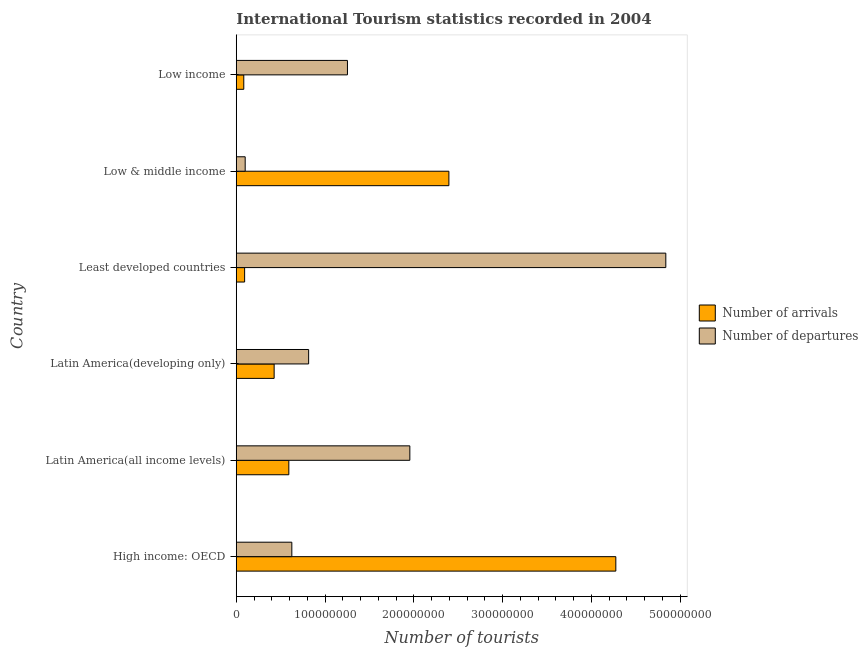How many different coloured bars are there?
Provide a short and direct response. 2. How many groups of bars are there?
Your answer should be compact. 6. Are the number of bars per tick equal to the number of legend labels?
Make the answer very short. Yes. How many bars are there on the 1st tick from the bottom?
Your answer should be compact. 2. What is the label of the 4th group of bars from the top?
Offer a very short reply. Latin America(developing only). What is the number of tourist departures in Low income?
Give a very brief answer. 1.25e+08. Across all countries, what is the maximum number of tourist departures?
Make the answer very short. 4.84e+08. Across all countries, what is the minimum number of tourist departures?
Offer a very short reply. 1.01e+07. In which country was the number of tourist arrivals maximum?
Provide a short and direct response. High income: OECD. What is the total number of tourist arrivals in the graph?
Your answer should be very brief. 7.87e+08. What is the difference between the number of tourist arrivals in High income: OECD and that in Low income?
Offer a terse response. 4.19e+08. What is the difference between the number of tourist arrivals in Least developed countries and the number of tourist departures in Latin America(all income levels)?
Provide a succinct answer. -1.86e+08. What is the average number of tourist departures per country?
Your answer should be very brief. 1.60e+08. What is the difference between the number of tourist departures and number of tourist arrivals in Low income?
Provide a succinct answer. 1.17e+08. What is the ratio of the number of tourist departures in High income: OECD to that in Least developed countries?
Your answer should be compact. 0.13. Is the number of tourist arrivals in High income: OECD less than that in Low income?
Your answer should be compact. No. What is the difference between the highest and the second highest number of tourist arrivals?
Provide a succinct answer. 1.88e+08. What is the difference between the highest and the lowest number of tourist arrivals?
Keep it short and to the point. 4.19e+08. What does the 1st bar from the top in Low & middle income represents?
Your answer should be very brief. Number of departures. What does the 1st bar from the bottom in Low income represents?
Ensure brevity in your answer.  Number of arrivals. Are all the bars in the graph horizontal?
Offer a terse response. Yes. How many countries are there in the graph?
Keep it short and to the point. 6. What is the difference between two consecutive major ticks on the X-axis?
Offer a terse response. 1.00e+08. Does the graph contain any zero values?
Ensure brevity in your answer.  No. Does the graph contain grids?
Keep it short and to the point. No. Where does the legend appear in the graph?
Give a very brief answer. Center right. What is the title of the graph?
Offer a very short reply. International Tourism statistics recorded in 2004. Does "Female entrants" appear as one of the legend labels in the graph?
Your answer should be very brief. No. What is the label or title of the X-axis?
Give a very brief answer. Number of tourists. What is the label or title of the Y-axis?
Your answer should be very brief. Country. What is the Number of tourists in Number of arrivals in High income: OECD?
Offer a very short reply. 4.28e+08. What is the Number of tourists of Number of departures in High income: OECD?
Provide a succinct answer. 6.26e+07. What is the Number of tourists of Number of arrivals in Latin America(all income levels)?
Provide a succinct answer. 5.92e+07. What is the Number of tourists of Number of departures in Latin America(all income levels)?
Provide a short and direct response. 1.96e+08. What is the Number of tourists in Number of arrivals in Latin America(developing only)?
Your response must be concise. 4.27e+07. What is the Number of tourists of Number of departures in Latin America(developing only)?
Offer a terse response. 8.16e+07. What is the Number of tourists of Number of arrivals in Least developed countries?
Make the answer very short. 9.43e+06. What is the Number of tourists of Number of departures in Least developed countries?
Your response must be concise. 4.84e+08. What is the Number of tourists of Number of arrivals in Low & middle income?
Offer a very short reply. 2.40e+08. What is the Number of tourists in Number of departures in Low & middle income?
Keep it short and to the point. 1.01e+07. What is the Number of tourists in Number of arrivals in Low income?
Provide a short and direct response. 8.48e+06. What is the Number of tourists in Number of departures in Low income?
Provide a succinct answer. 1.25e+08. Across all countries, what is the maximum Number of tourists of Number of arrivals?
Provide a succinct answer. 4.28e+08. Across all countries, what is the maximum Number of tourists in Number of departures?
Offer a terse response. 4.84e+08. Across all countries, what is the minimum Number of tourists in Number of arrivals?
Give a very brief answer. 8.48e+06. Across all countries, what is the minimum Number of tourists of Number of departures?
Offer a very short reply. 1.01e+07. What is the total Number of tourists in Number of arrivals in the graph?
Your answer should be compact. 7.87e+08. What is the total Number of tourists in Number of departures in the graph?
Give a very brief answer. 9.59e+08. What is the difference between the Number of tourists of Number of arrivals in High income: OECD and that in Latin America(all income levels)?
Ensure brevity in your answer.  3.68e+08. What is the difference between the Number of tourists in Number of departures in High income: OECD and that in Latin America(all income levels)?
Offer a very short reply. -1.33e+08. What is the difference between the Number of tourists in Number of arrivals in High income: OECD and that in Latin America(developing only)?
Offer a very short reply. 3.85e+08. What is the difference between the Number of tourists in Number of departures in High income: OECD and that in Latin America(developing only)?
Offer a terse response. -1.90e+07. What is the difference between the Number of tourists of Number of arrivals in High income: OECD and that in Least developed countries?
Give a very brief answer. 4.18e+08. What is the difference between the Number of tourists of Number of departures in High income: OECD and that in Least developed countries?
Make the answer very short. -4.21e+08. What is the difference between the Number of tourists of Number of arrivals in High income: OECD and that in Low & middle income?
Keep it short and to the point. 1.88e+08. What is the difference between the Number of tourists of Number of departures in High income: OECD and that in Low & middle income?
Your response must be concise. 5.25e+07. What is the difference between the Number of tourists of Number of arrivals in High income: OECD and that in Low income?
Your response must be concise. 4.19e+08. What is the difference between the Number of tourists in Number of departures in High income: OECD and that in Low income?
Your answer should be compact. -6.27e+07. What is the difference between the Number of tourists in Number of arrivals in Latin America(all income levels) and that in Latin America(developing only)?
Offer a terse response. 1.66e+07. What is the difference between the Number of tourists in Number of departures in Latin America(all income levels) and that in Latin America(developing only)?
Make the answer very short. 1.14e+08. What is the difference between the Number of tourists of Number of arrivals in Latin America(all income levels) and that in Least developed countries?
Provide a succinct answer. 4.98e+07. What is the difference between the Number of tourists in Number of departures in Latin America(all income levels) and that in Least developed countries?
Keep it short and to the point. -2.88e+08. What is the difference between the Number of tourists of Number of arrivals in Latin America(all income levels) and that in Low & middle income?
Keep it short and to the point. -1.80e+08. What is the difference between the Number of tourists of Number of departures in Latin America(all income levels) and that in Low & middle income?
Offer a terse response. 1.86e+08. What is the difference between the Number of tourists in Number of arrivals in Latin America(all income levels) and that in Low income?
Offer a terse response. 5.08e+07. What is the difference between the Number of tourists in Number of departures in Latin America(all income levels) and that in Low income?
Provide a succinct answer. 7.03e+07. What is the difference between the Number of tourists in Number of arrivals in Latin America(developing only) and that in Least developed countries?
Make the answer very short. 3.33e+07. What is the difference between the Number of tourists of Number of departures in Latin America(developing only) and that in Least developed countries?
Ensure brevity in your answer.  -4.02e+08. What is the difference between the Number of tourists in Number of arrivals in Latin America(developing only) and that in Low & middle income?
Provide a short and direct response. -1.97e+08. What is the difference between the Number of tourists of Number of departures in Latin America(developing only) and that in Low & middle income?
Your response must be concise. 7.15e+07. What is the difference between the Number of tourists of Number of arrivals in Latin America(developing only) and that in Low income?
Provide a succinct answer. 3.42e+07. What is the difference between the Number of tourists of Number of departures in Latin America(developing only) and that in Low income?
Give a very brief answer. -4.37e+07. What is the difference between the Number of tourists in Number of arrivals in Least developed countries and that in Low & middle income?
Offer a very short reply. -2.30e+08. What is the difference between the Number of tourists of Number of departures in Least developed countries and that in Low & middle income?
Your response must be concise. 4.74e+08. What is the difference between the Number of tourists in Number of arrivals in Least developed countries and that in Low income?
Offer a terse response. 9.46e+05. What is the difference between the Number of tourists of Number of departures in Least developed countries and that in Low income?
Your answer should be compact. 3.59e+08. What is the difference between the Number of tourists in Number of arrivals in Low & middle income and that in Low income?
Give a very brief answer. 2.31e+08. What is the difference between the Number of tourists of Number of departures in Low & middle income and that in Low income?
Give a very brief answer. -1.15e+08. What is the difference between the Number of tourists in Number of arrivals in High income: OECD and the Number of tourists in Number of departures in Latin America(all income levels)?
Your response must be concise. 2.32e+08. What is the difference between the Number of tourists in Number of arrivals in High income: OECD and the Number of tourists in Number of departures in Latin America(developing only)?
Your response must be concise. 3.46e+08. What is the difference between the Number of tourists in Number of arrivals in High income: OECD and the Number of tourists in Number of departures in Least developed countries?
Ensure brevity in your answer.  -5.63e+07. What is the difference between the Number of tourists in Number of arrivals in High income: OECD and the Number of tourists in Number of departures in Low & middle income?
Offer a terse response. 4.18e+08. What is the difference between the Number of tourists in Number of arrivals in High income: OECD and the Number of tourists in Number of departures in Low income?
Offer a very short reply. 3.02e+08. What is the difference between the Number of tourists in Number of arrivals in Latin America(all income levels) and the Number of tourists in Number of departures in Latin America(developing only)?
Offer a very short reply. -2.23e+07. What is the difference between the Number of tourists in Number of arrivals in Latin America(all income levels) and the Number of tourists in Number of departures in Least developed countries?
Your answer should be very brief. -4.25e+08. What is the difference between the Number of tourists of Number of arrivals in Latin America(all income levels) and the Number of tourists of Number of departures in Low & middle income?
Keep it short and to the point. 4.92e+07. What is the difference between the Number of tourists of Number of arrivals in Latin America(all income levels) and the Number of tourists of Number of departures in Low income?
Make the answer very short. -6.60e+07. What is the difference between the Number of tourists of Number of arrivals in Latin America(developing only) and the Number of tourists of Number of departures in Least developed countries?
Provide a succinct answer. -4.41e+08. What is the difference between the Number of tourists of Number of arrivals in Latin America(developing only) and the Number of tourists of Number of departures in Low & middle income?
Provide a short and direct response. 3.26e+07. What is the difference between the Number of tourists in Number of arrivals in Latin America(developing only) and the Number of tourists in Number of departures in Low income?
Give a very brief answer. -8.26e+07. What is the difference between the Number of tourists of Number of arrivals in Least developed countries and the Number of tourists of Number of departures in Low & middle income?
Make the answer very short. -6.32e+05. What is the difference between the Number of tourists in Number of arrivals in Least developed countries and the Number of tourists in Number of departures in Low income?
Make the answer very short. -1.16e+08. What is the difference between the Number of tourists in Number of arrivals in Low & middle income and the Number of tourists in Number of departures in Low income?
Provide a short and direct response. 1.14e+08. What is the average Number of tourists in Number of arrivals per country?
Your answer should be compact. 1.31e+08. What is the average Number of tourists in Number of departures per country?
Make the answer very short. 1.60e+08. What is the difference between the Number of tourists in Number of arrivals and Number of tourists in Number of departures in High income: OECD?
Your response must be concise. 3.65e+08. What is the difference between the Number of tourists of Number of arrivals and Number of tourists of Number of departures in Latin America(all income levels)?
Provide a succinct answer. -1.36e+08. What is the difference between the Number of tourists of Number of arrivals and Number of tourists of Number of departures in Latin America(developing only)?
Your answer should be very brief. -3.89e+07. What is the difference between the Number of tourists of Number of arrivals and Number of tourists of Number of departures in Least developed countries?
Give a very brief answer. -4.75e+08. What is the difference between the Number of tourists in Number of arrivals and Number of tourists in Number of departures in Low & middle income?
Your response must be concise. 2.29e+08. What is the difference between the Number of tourists in Number of arrivals and Number of tourists in Number of departures in Low income?
Your answer should be very brief. -1.17e+08. What is the ratio of the Number of tourists of Number of arrivals in High income: OECD to that in Latin America(all income levels)?
Ensure brevity in your answer.  7.22. What is the ratio of the Number of tourists of Number of departures in High income: OECD to that in Latin America(all income levels)?
Ensure brevity in your answer.  0.32. What is the ratio of the Number of tourists of Number of arrivals in High income: OECD to that in Latin America(developing only)?
Make the answer very short. 10.02. What is the ratio of the Number of tourists of Number of departures in High income: OECD to that in Latin America(developing only)?
Provide a short and direct response. 0.77. What is the ratio of the Number of tourists of Number of arrivals in High income: OECD to that in Least developed countries?
Offer a terse response. 45.36. What is the ratio of the Number of tourists of Number of departures in High income: OECD to that in Least developed countries?
Ensure brevity in your answer.  0.13. What is the ratio of the Number of tourists in Number of arrivals in High income: OECD to that in Low & middle income?
Provide a succinct answer. 1.79. What is the ratio of the Number of tourists of Number of departures in High income: OECD to that in Low & middle income?
Provide a short and direct response. 6.22. What is the ratio of the Number of tourists of Number of arrivals in High income: OECD to that in Low income?
Your answer should be compact. 50.42. What is the ratio of the Number of tourists of Number of departures in High income: OECD to that in Low income?
Keep it short and to the point. 0.5. What is the ratio of the Number of tourists in Number of arrivals in Latin America(all income levels) to that in Latin America(developing only)?
Keep it short and to the point. 1.39. What is the ratio of the Number of tourists in Number of departures in Latin America(all income levels) to that in Latin America(developing only)?
Offer a terse response. 2.4. What is the ratio of the Number of tourists of Number of arrivals in Latin America(all income levels) to that in Least developed countries?
Give a very brief answer. 6.28. What is the ratio of the Number of tourists in Number of departures in Latin America(all income levels) to that in Least developed countries?
Ensure brevity in your answer.  0.4. What is the ratio of the Number of tourists of Number of arrivals in Latin America(all income levels) to that in Low & middle income?
Give a very brief answer. 0.25. What is the ratio of the Number of tourists in Number of departures in Latin America(all income levels) to that in Low & middle income?
Provide a succinct answer. 19.44. What is the ratio of the Number of tourists in Number of arrivals in Latin America(all income levels) to that in Low income?
Offer a very short reply. 6.98. What is the ratio of the Number of tourists in Number of departures in Latin America(all income levels) to that in Low income?
Give a very brief answer. 1.56. What is the ratio of the Number of tourists of Number of arrivals in Latin America(developing only) to that in Least developed countries?
Keep it short and to the point. 4.53. What is the ratio of the Number of tourists in Number of departures in Latin America(developing only) to that in Least developed countries?
Give a very brief answer. 0.17. What is the ratio of the Number of tourists of Number of arrivals in Latin America(developing only) to that in Low & middle income?
Offer a terse response. 0.18. What is the ratio of the Number of tourists in Number of departures in Latin America(developing only) to that in Low & middle income?
Provide a succinct answer. 8.11. What is the ratio of the Number of tourists of Number of arrivals in Latin America(developing only) to that in Low income?
Offer a terse response. 5.03. What is the ratio of the Number of tourists of Number of departures in Latin America(developing only) to that in Low income?
Give a very brief answer. 0.65. What is the ratio of the Number of tourists in Number of arrivals in Least developed countries to that in Low & middle income?
Your answer should be very brief. 0.04. What is the ratio of the Number of tourists of Number of departures in Least developed countries to that in Low & middle income?
Your answer should be very brief. 48.11. What is the ratio of the Number of tourists in Number of arrivals in Least developed countries to that in Low income?
Provide a short and direct response. 1.11. What is the ratio of the Number of tourists of Number of departures in Least developed countries to that in Low income?
Provide a short and direct response. 3.86. What is the ratio of the Number of tourists in Number of arrivals in Low & middle income to that in Low income?
Keep it short and to the point. 28.24. What is the ratio of the Number of tourists of Number of departures in Low & middle income to that in Low income?
Give a very brief answer. 0.08. What is the difference between the highest and the second highest Number of tourists in Number of arrivals?
Provide a short and direct response. 1.88e+08. What is the difference between the highest and the second highest Number of tourists in Number of departures?
Your answer should be very brief. 2.88e+08. What is the difference between the highest and the lowest Number of tourists of Number of arrivals?
Make the answer very short. 4.19e+08. What is the difference between the highest and the lowest Number of tourists in Number of departures?
Your answer should be compact. 4.74e+08. 